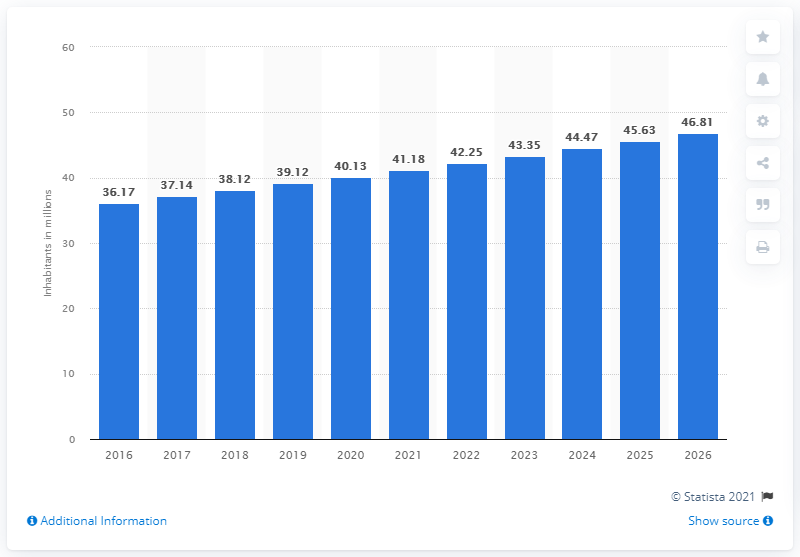Give some essential details in this illustration. The population of Iraq in 2020 was approximately 40.13 million. 